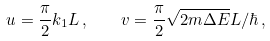Convert formula to latex. <formula><loc_0><loc_0><loc_500><loc_500>u = \frac { \pi } { 2 } k _ { 1 } L \, , \quad v = \frac { \pi } { 2 } \sqrt { 2 m \Delta E } L / \hbar { \, } ,</formula> 